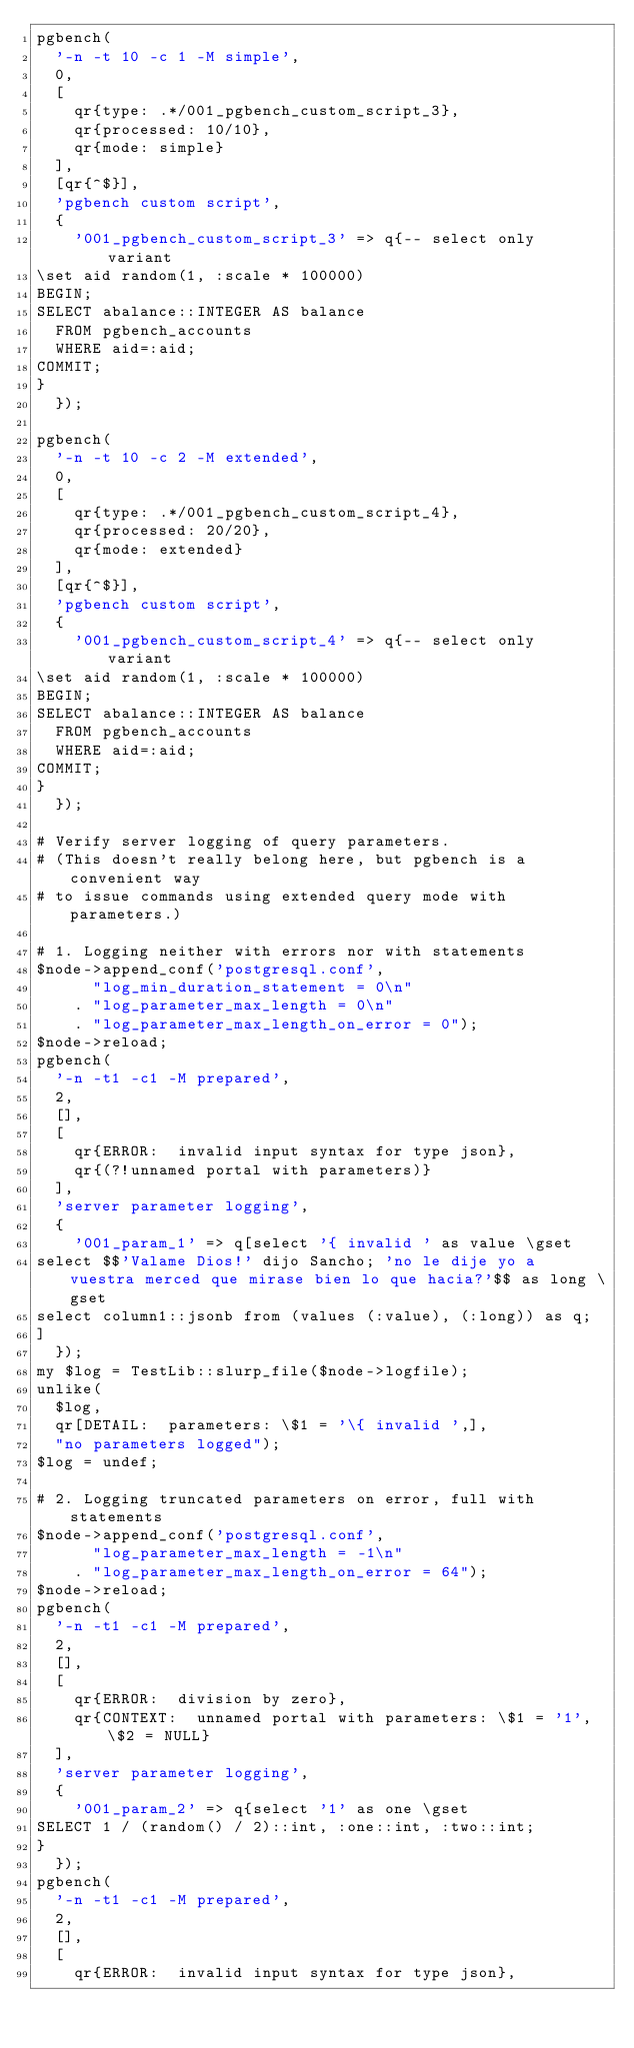<code> <loc_0><loc_0><loc_500><loc_500><_Perl_>pgbench(
	'-n -t 10 -c 1 -M simple',
	0,
	[
		qr{type: .*/001_pgbench_custom_script_3},
		qr{processed: 10/10},
		qr{mode: simple}
	],
	[qr{^$}],
	'pgbench custom script',
	{
		'001_pgbench_custom_script_3' => q{-- select only variant
\set aid random(1, :scale * 100000)
BEGIN;
SELECT abalance::INTEGER AS balance
  FROM pgbench_accounts
  WHERE aid=:aid;
COMMIT;
}
	});

pgbench(
	'-n -t 10 -c 2 -M extended',
	0,
	[
		qr{type: .*/001_pgbench_custom_script_4},
		qr{processed: 20/20},
		qr{mode: extended}
	],
	[qr{^$}],
	'pgbench custom script',
	{
		'001_pgbench_custom_script_4' => q{-- select only variant
\set aid random(1, :scale * 100000)
BEGIN;
SELECT abalance::INTEGER AS balance
  FROM pgbench_accounts
  WHERE aid=:aid;
COMMIT;
}
	});

# Verify server logging of query parameters.
# (This doesn't really belong here, but pgbench is a convenient way
# to issue commands using extended query mode with parameters.)

# 1. Logging neither with errors nor with statements
$node->append_conf('postgresql.conf',
	    "log_min_duration_statement = 0\n"
	  . "log_parameter_max_length = 0\n"
	  . "log_parameter_max_length_on_error = 0");
$node->reload;
pgbench(
	'-n -t1 -c1 -M prepared',
	2,
	[],
	[
		qr{ERROR:  invalid input syntax for type json},
		qr{(?!unnamed portal with parameters)}
	],
	'server parameter logging',
	{
		'001_param_1' => q[select '{ invalid ' as value \gset
select $$'Valame Dios!' dijo Sancho; 'no le dije yo a vuestra merced que mirase bien lo que hacia?'$$ as long \gset
select column1::jsonb from (values (:value), (:long)) as q;
]
	});
my $log = TestLib::slurp_file($node->logfile);
unlike(
	$log,
	qr[DETAIL:  parameters: \$1 = '\{ invalid ',],
	"no parameters logged");
$log = undef;

# 2. Logging truncated parameters on error, full with statements
$node->append_conf('postgresql.conf',
	    "log_parameter_max_length = -1\n"
	  . "log_parameter_max_length_on_error = 64");
$node->reload;
pgbench(
	'-n -t1 -c1 -M prepared',
	2,
	[],
	[
		qr{ERROR:  division by zero},
		qr{CONTEXT:  unnamed portal with parameters: \$1 = '1', \$2 = NULL}
	],
	'server parameter logging',
	{
		'001_param_2' => q{select '1' as one \gset
SELECT 1 / (random() / 2)::int, :one::int, :two::int;
}
	});
pgbench(
	'-n -t1 -c1 -M prepared',
	2,
	[],
	[
		qr{ERROR:  invalid input syntax for type json},</code> 